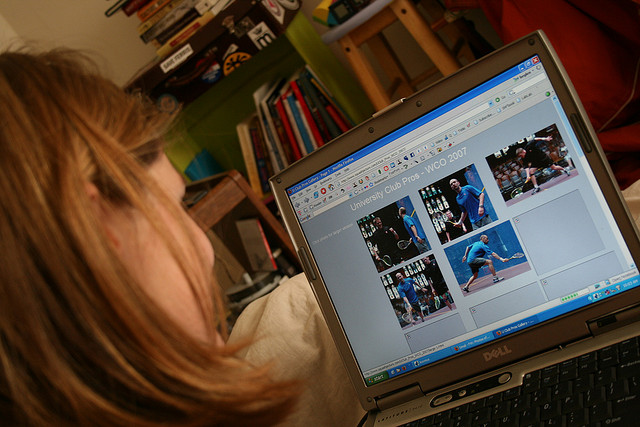<image>What is the person's name in the image? It is unknown what the person's name in the image is. How old is this picture? It is ambiguous to determine how old the picture is. It can be slightly old, not old, a day old or even 10 years.
 What hand does the woman have on the touchpad? I don't know what hand the woman has on the touchpad. It is possible that no hands are visible. What channel is being shown? It's unknown what channel is being shown. It could be possibly 'tennis', 'wco', 'espn', 'waco', 'youtube' or 'university club pros'. What is the person's name in the image? I am not sure what the person's name is in the image. How old is this picture? It is unknown how old is this picture. It is not very old. What hand does the woman have on the touchpad? I don't know what hand does the woman have on the touchpad. It is not visible. What channel is being shown? It is ambiguous what channel is being shown. It can be either 'tennis', 'wco', 'espn' or 'waco'. 